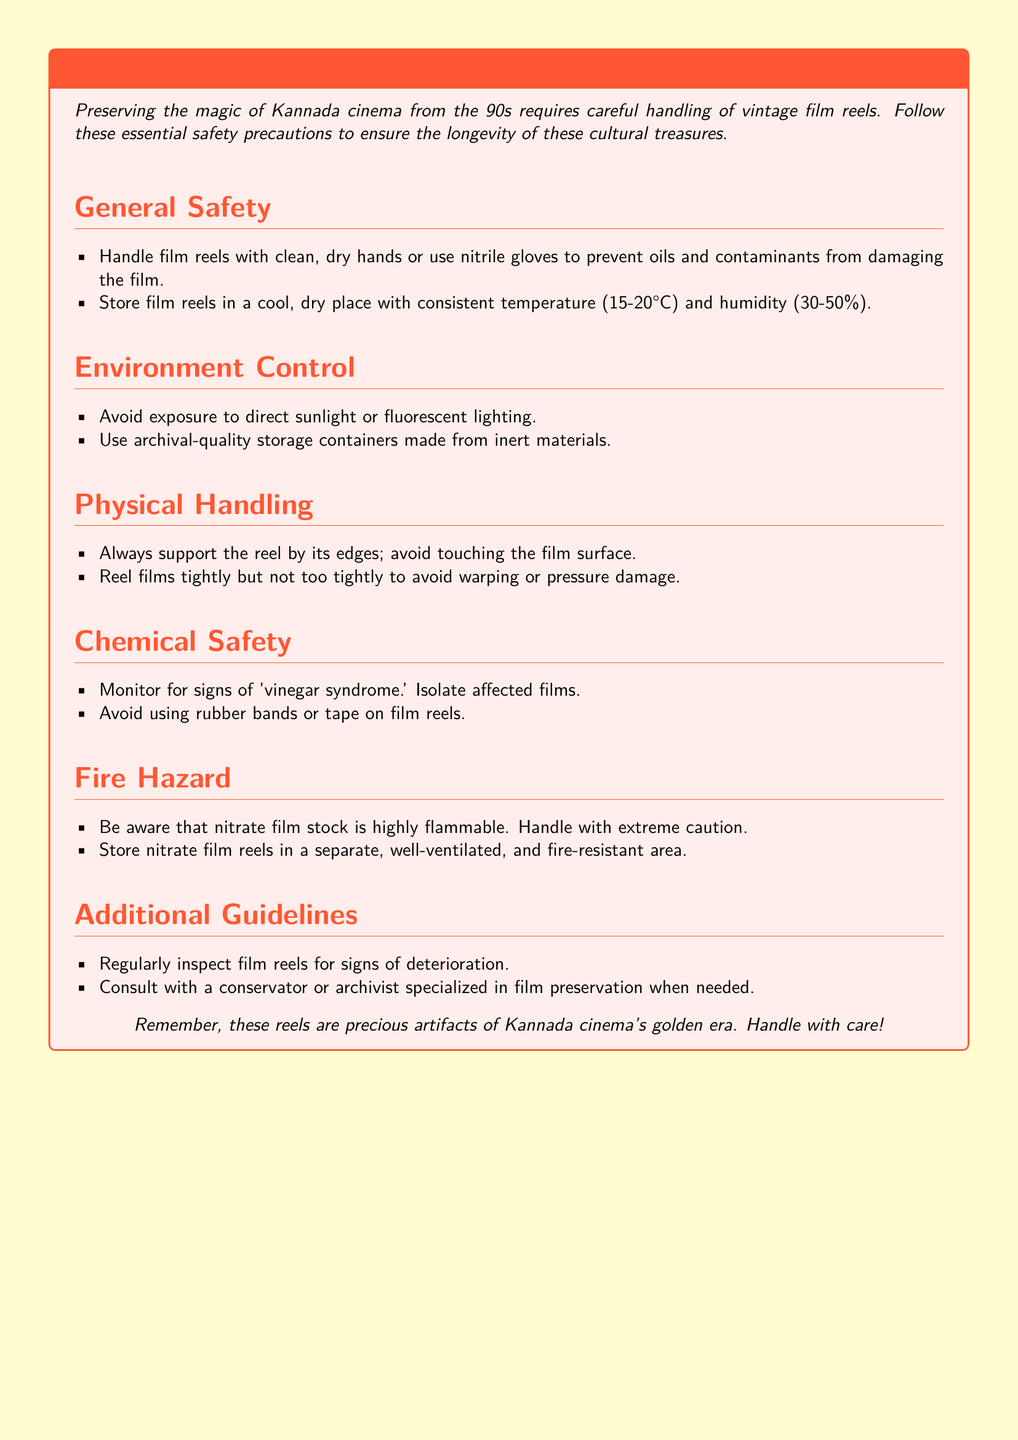what is the recommended temperature range for storing film reels? The document specifies that film reels should be stored at a consistent temperature between 15-20°C.
Answer: 15-20°C what materials should be used for storage containers? The document advises using archival-quality storage containers made from inert materials.
Answer: inert materials what is a key sign of deterioration in film? According to the document, 'vinegar syndrome' is a sign of deterioration in film.
Answer: vinegar syndrome how should one support film reels during handling? It is advised to support the reel by its edges to avoid damage.
Answer: edges where should nitrate film reels be stored? The document states that nitrate film reels should be stored in a separate, well-ventilated, and fire-resistant area.
Answer: separate, well-ventilated, and fire-resistant area what is the humidity range suitable for storing film reels? The suggested humidity range for storing film reels is 30-50%.
Answer: 30-50% why should film not be tightly rolled? The document warns against tightly rolling film to prevent warping or pressure damage.
Answer: warping or pressure damage what is essential to wear while handling film reels? The document recommends wearing nitrile gloves or having clean, dry hands while handling film reels.
Answer: nitrile gloves or clean, dry hands how often should film reels be inspected? The document implies that film reels should be inspected regularly for signs of deterioration.
Answer: regularly 